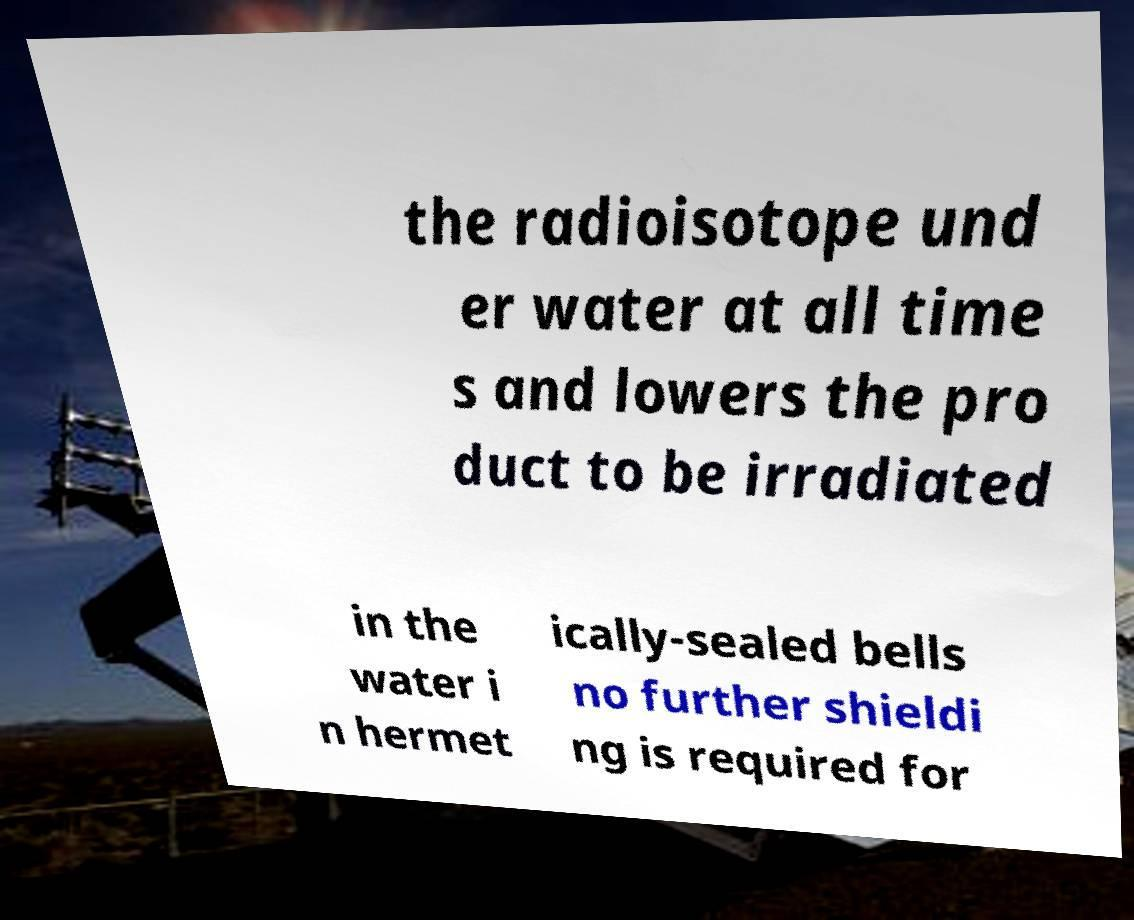Please read and relay the text visible in this image. What does it say? the radioisotope und er water at all time s and lowers the pro duct to be irradiated in the water i n hermet ically-sealed bells no further shieldi ng is required for 